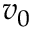<formula> <loc_0><loc_0><loc_500><loc_500>v _ { 0 }</formula> 